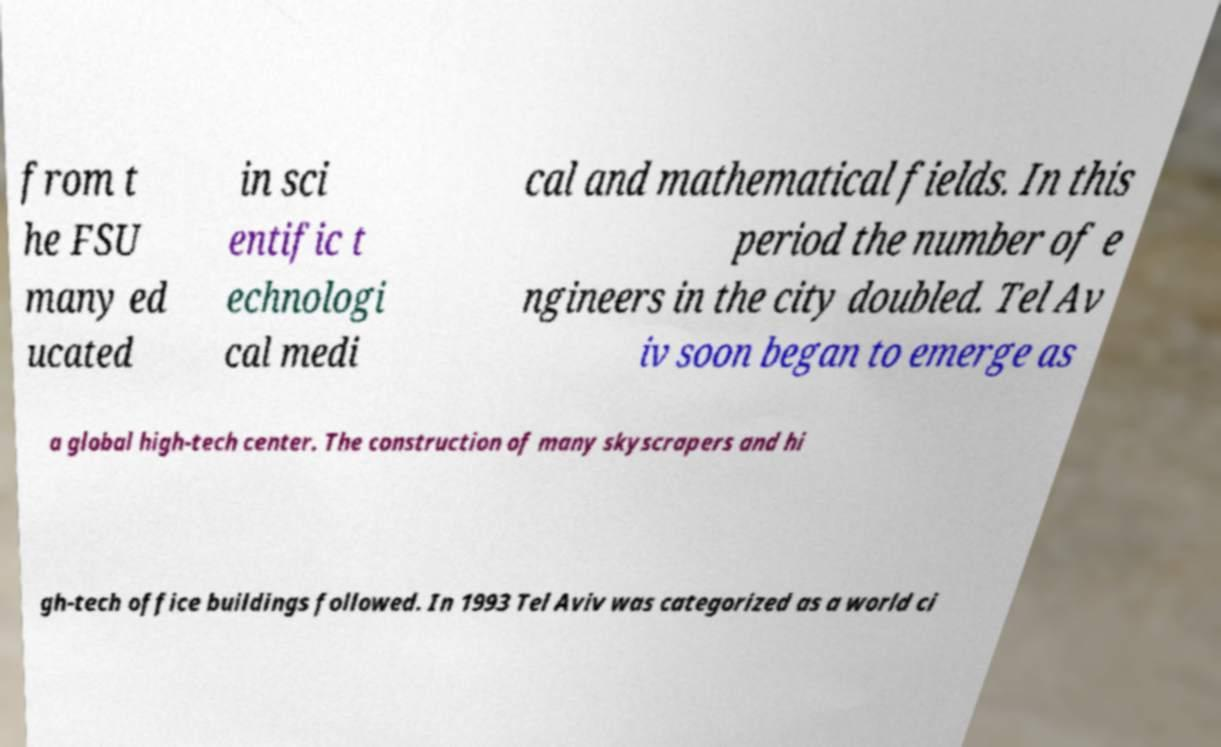Please read and relay the text visible in this image. What does it say? from t he FSU many ed ucated in sci entific t echnologi cal medi cal and mathematical fields. In this period the number of e ngineers in the city doubled. Tel Av iv soon began to emerge as a global high-tech center. The construction of many skyscrapers and hi gh-tech office buildings followed. In 1993 Tel Aviv was categorized as a world ci 